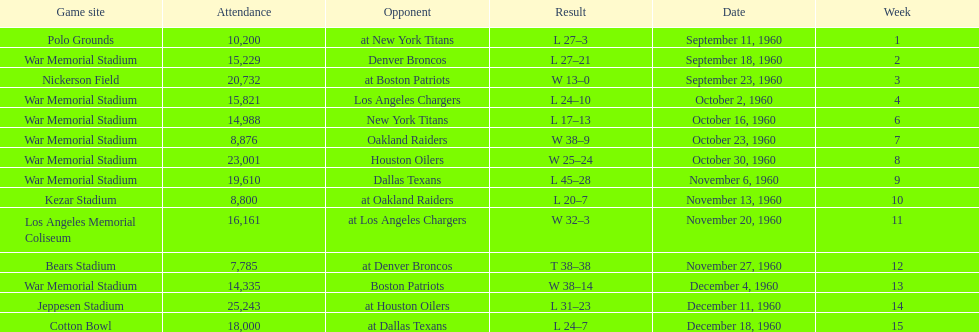Who was the only opponent they played which resulted in a tie game? Denver Broncos. 